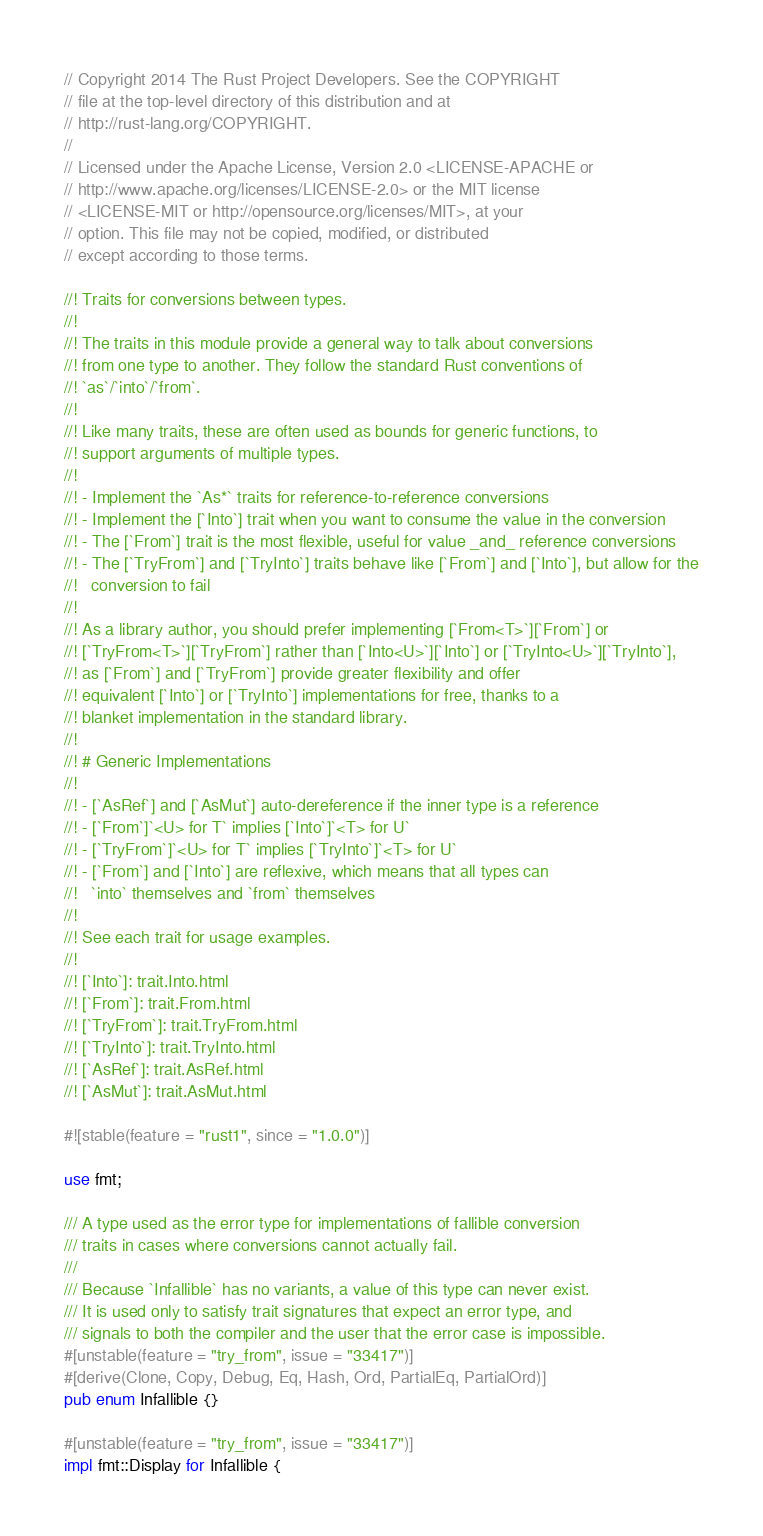Convert code to text. <code><loc_0><loc_0><loc_500><loc_500><_Rust_>// Copyright 2014 The Rust Project Developers. See the COPYRIGHT
// file at the top-level directory of this distribution and at
// http://rust-lang.org/COPYRIGHT.
//
// Licensed under the Apache License, Version 2.0 <LICENSE-APACHE or
// http://www.apache.org/licenses/LICENSE-2.0> or the MIT license
// <LICENSE-MIT or http://opensource.org/licenses/MIT>, at your
// option. This file may not be copied, modified, or distributed
// except according to those terms.

//! Traits for conversions between types.
//!
//! The traits in this module provide a general way to talk about conversions
//! from one type to another. They follow the standard Rust conventions of
//! `as`/`into`/`from`.
//!
//! Like many traits, these are often used as bounds for generic functions, to
//! support arguments of multiple types.
//!
//! - Implement the `As*` traits for reference-to-reference conversions
//! - Implement the [`Into`] trait when you want to consume the value in the conversion
//! - The [`From`] trait is the most flexible, useful for value _and_ reference conversions
//! - The [`TryFrom`] and [`TryInto`] traits behave like [`From`] and [`Into`], but allow for the
//!   conversion to fail
//!
//! As a library author, you should prefer implementing [`From<T>`][`From`] or
//! [`TryFrom<T>`][`TryFrom`] rather than [`Into<U>`][`Into`] or [`TryInto<U>`][`TryInto`],
//! as [`From`] and [`TryFrom`] provide greater flexibility and offer
//! equivalent [`Into`] or [`TryInto`] implementations for free, thanks to a
//! blanket implementation in the standard library.
//!
//! # Generic Implementations
//!
//! - [`AsRef`] and [`AsMut`] auto-dereference if the inner type is a reference
//! - [`From`]`<U> for T` implies [`Into`]`<T> for U`
//! - [`TryFrom`]`<U> for T` implies [`TryInto`]`<T> for U`
//! - [`From`] and [`Into`] are reflexive, which means that all types can
//!   `into` themselves and `from` themselves
//!
//! See each trait for usage examples.
//!
//! [`Into`]: trait.Into.html
//! [`From`]: trait.From.html
//! [`TryFrom`]: trait.TryFrom.html
//! [`TryInto`]: trait.TryInto.html
//! [`AsRef`]: trait.AsRef.html
//! [`AsMut`]: trait.AsMut.html

#![stable(feature = "rust1", since = "1.0.0")]

use fmt;

/// A type used as the error type for implementations of fallible conversion
/// traits in cases where conversions cannot actually fail.
///
/// Because `Infallible` has no variants, a value of this type can never exist.
/// It is used only to satisfy trait signatures that expect an error type, and
/// signals to both the compiler and the user that the error case is impossible.
#[unstable(feature = "try_from", issue = "33417")]
#[derive(Clone, Copy, Debug, Eq, Hash, Ord, PartialEq, PartialOrd)]
pub enum Infallible {}

#[unstable(feature = "try_from", issue = "33417")]
impl fmt::Display for Infallible {</code> 